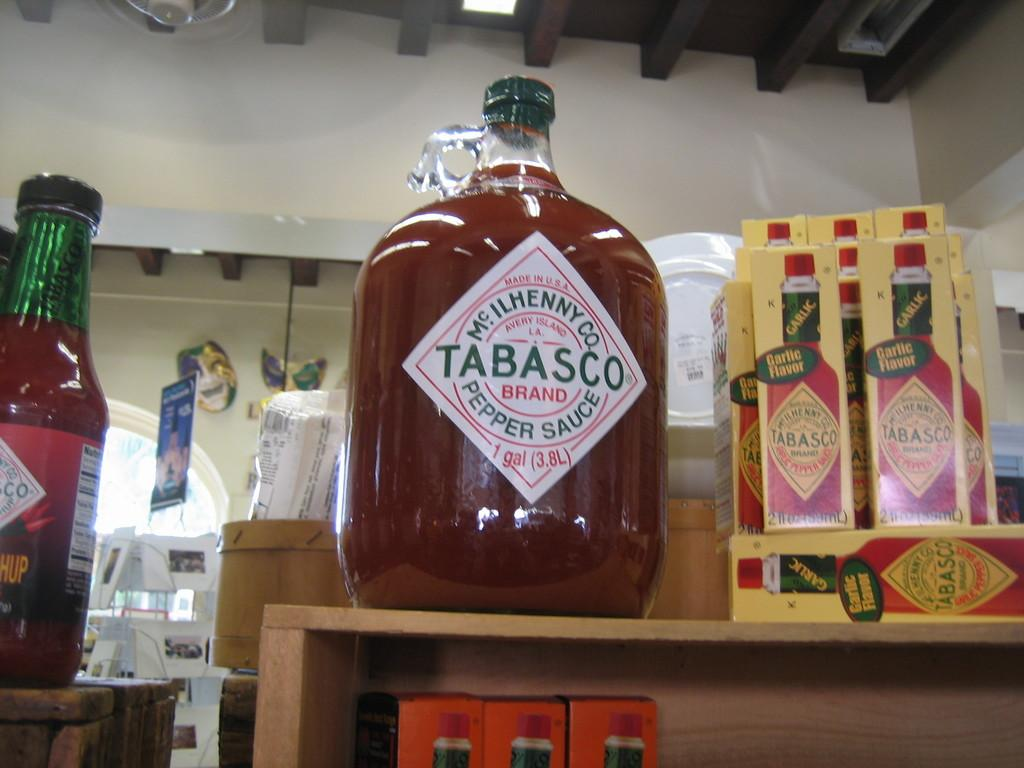Provide a one-sentence caption for the provided image. A really gigantic jug of Tabasco Sauce on a store display. 